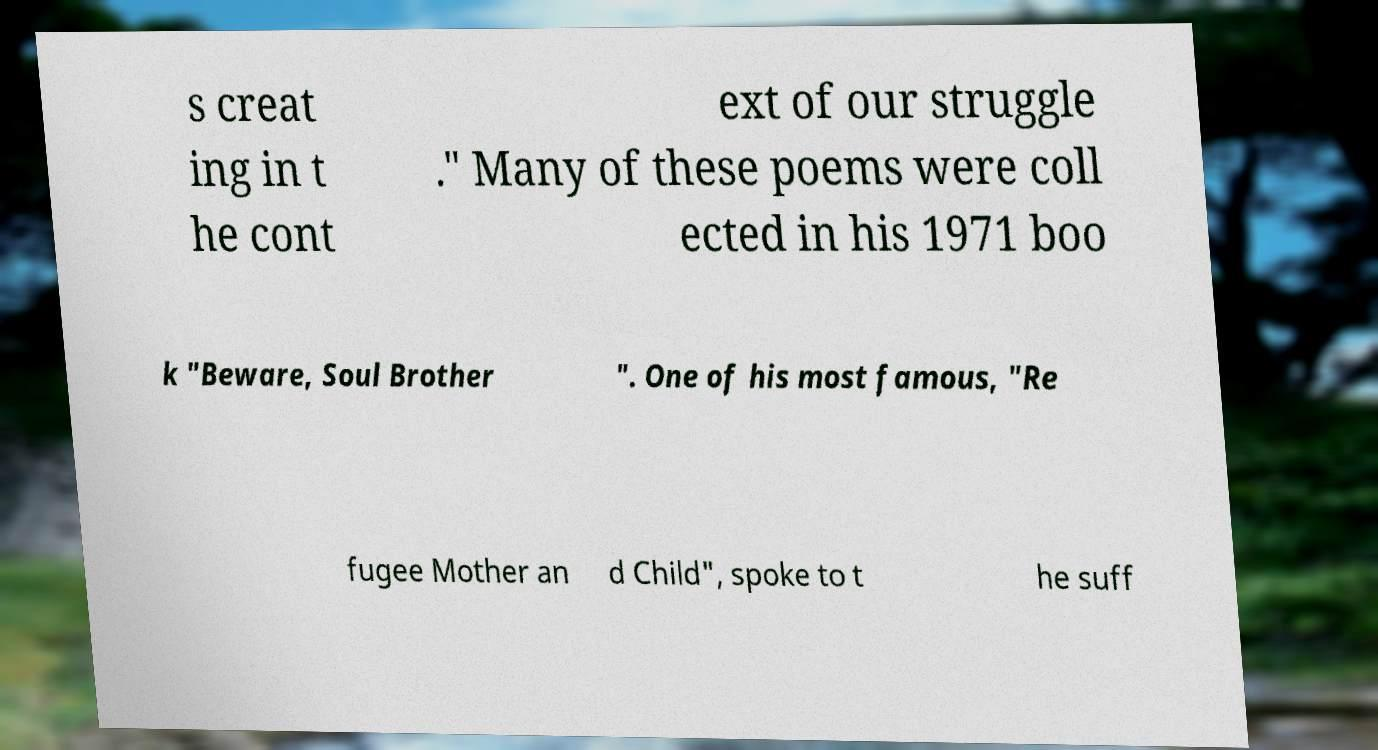Please read and relay the text visible in this image. What does it say? s creat ing in t he cont ext of our struggle ." Many of these poems were coll ected in his 1971 boo k "Beware, Soul Brother ". One of his most famous, "Re fugee Mother an d Child", spoke to t he suff 